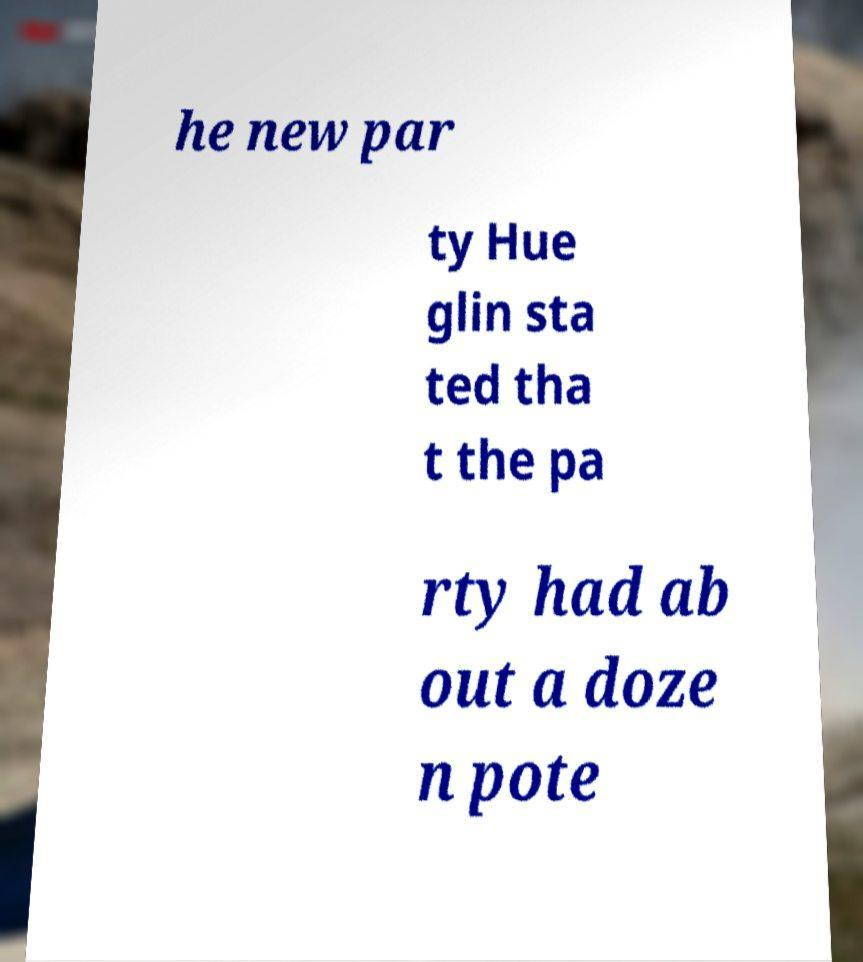For documentation purposes, I need the text within this image transcribed. Could you provide that? he new par ty Hue glin sta ted tha t the pa rty had ab out a doze n pote 